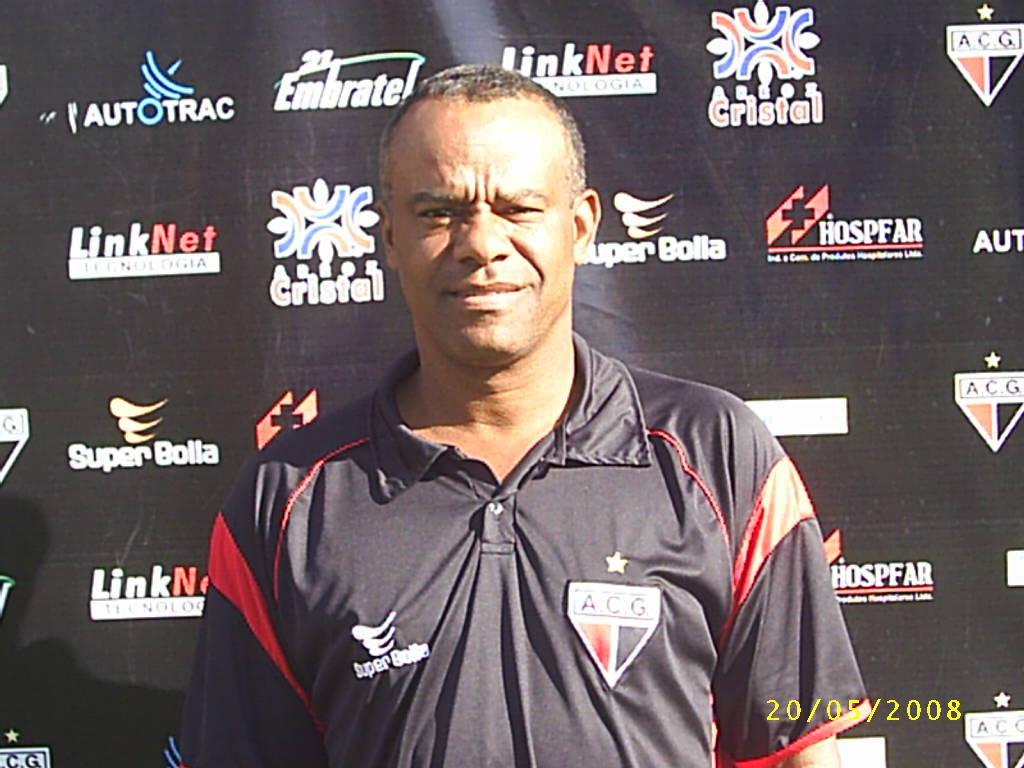What is the name of the sponsor second top from left?
Offer a very short reply. Embratel. Whats the name of the very top left sponsor behind the man on the wall?
Give a very brief answer. Autotrac. 